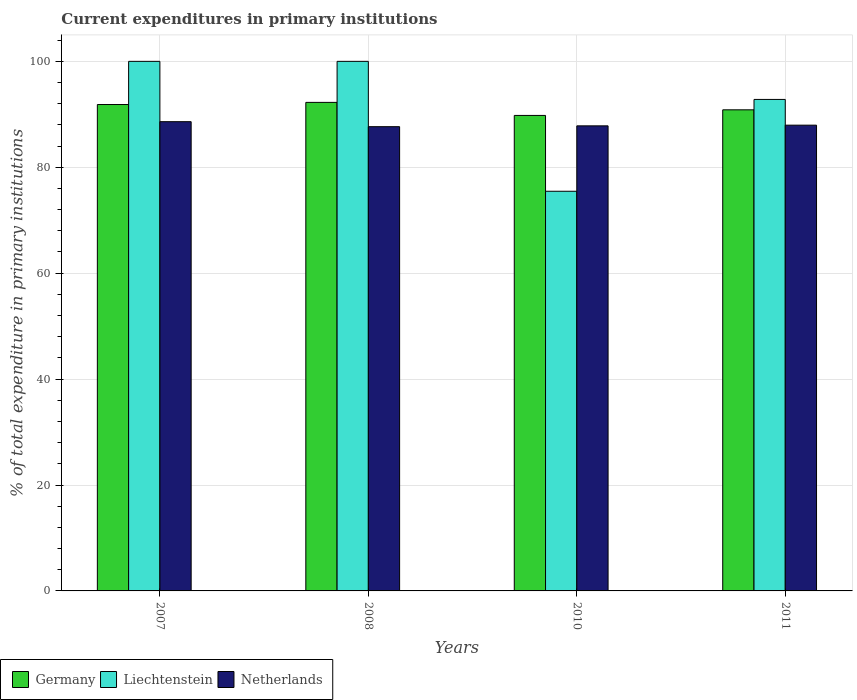How many different coloured bars are there?
Offer a very short reply. 3. Are the number of bars per tick equal to the number of legend labels?
Provide a short and direct response. Yes. How many bars are there on the 1st tick from the left?
Offer a terse response. 3. In how many cases, is the number of bars for a given year not equal to the number of legend labels?
Your answer should be very brief. 0. What is the current expenditures in primary institutions in Liechtenstein in 2008?
Your answer should be very brief. 100. Across all years, what is the maximum current expenditures in primary institutions in Germany?
Your answer should be very brief. 92.25. Across all years, what is the minimum current expenditures in primary institutions in Netherlands?
Provide a short and direct response. 87.67. In which year was the current expenditures in primary institutions in Liechtenstein minimum?
Your answer should be compact. 2010. What is the total current expenditures in primary institutions in Netherlands in the graph?
Keep it short and to the point. 352.04. What is the difference between the current expenditures in primary institutions in Germany in 2007 and that in 2010?
Provide a short and direct response. 2.06. What is the difference between the current expenditures in primary institutions in Liechtenstein in 2008 and the current expenditures in primary institutions in Germany in 2011?
Provide a succinct answer. 9.15. What is the average current expenditures in primary institutions in Germany per year?
Your response must be concise. 91.18. In the year 2008, what is the difference between the current expenditures in primary institutions in Netherlands and current expenditures in primary institutions in Liechtenstein?
Your response must be concise. -12.33. In how many years, is the current expenditures in primary institutions in Netherlands greater than 88 %?
Give a very brief answer. 1. What is the ratio of the current expenditures in primary institutions in Liechtenstein in 2008 to that in 2010?
Your answer should be compact. 1.33. Is the difference between the current expenditures in primary institutions in Netherlands in 2008 and 2010 greater than the difference between the current expenditures in primary institutions in Liechtenstein in 2008 and 2010?
Make the answer very short. No. What is the difference between the highest and the second highest current expenditures in primary institutions in Germany?
Give a very brief answer. 0.4. What is the difference between the highest and the lowest current expenditures in primary institutions in Liechtenstein?
Give a very brief answer. 24.53. In how many years, is the current expenditures in primary institutions in Liechtenstein greater than the average current expenditures in primary institutions in Liechtenstein taken over all years?
Provide a short and direct response. 3. What does the 2nd bar from the left in 2008 represents?
Keep it short and to the point. Liechtenstein. What does the 2nd bar from the right in 2011 represents?
Offer a very short reply. Liechtenstein. Are all the bars in the graph horizontal?
Your answer should be very brief. No. What is the difference between two consecutive major ticks on the Y-axis?
Your response must be concise. 20. Does the graph contain any zero values?
Your response must be concise. No. How many legend labels are there?
Ensure brevity in your answer.  3. What is the title of the graph?
Provide a succinct answer. Current expenditures in primary institutions. What is the label or title of the X-axis?
Your response must be concise. Years. What is the label or title of the Y-axis?
Keep it short and to the point. % of total expenditure in primary institutions. What is the % of total expenditure in primary institutions in Germany in 2007?
Your response must be concise. 91.85. What is the % of total expenditure in primary institutions of Liechtenstein in 2007?
Offer a terse response. 100. What is the % of total expenditure in primary institutions in Netherlands in 2007?
Provide a succinct answer. 88.61. What is the % of total expenditure in primary institutions in Germany in 2008?
Offer a terse response. 92.25. What is the % of total expenditure in primary institutions of Netherlands in 2008?
Provide a succinct answer. 87.67. What is the % of total expenditure in primary institutions of Germany in 2010?
Your response must be concise. 89.79. What is the % of total expenditure in primary institutions in Liechtenstein in 2010?
Ensure brevity in your answer.  75.47. What is the % of total expenditure in primary institutions in Netherlands in 2010?
Your answer should be compact. 87.82. What is the % of total expenditure in primary institutions in Germany in 2011?
Offer a very short reply. 90.85. What is the % of total expenditure in primary institutions in Liechtenstein in 2011?
Make the answer very short. 92.81. What is the % of total expenditure in primary institutions in Netherlands in 2011?
Offer a terse response. 87.95. Across all years, what is the maximum % of total expenditure in primary institutions in Germany?
Provide a short and direct response. 92.25. Across all years, what is the maximum % of total expenditure in primary institutions in Liechtenstein?
Ensure brevity in your answer.  100. Across all years, what is the maximum % of total expenditure in primary institutions in Netherlands?
Offer a very short reply. 88.61. Across all years, what is the minimum % of total expenditure in primary institutions of Germany?
Your response must be concise. 89.79. Across all years, what is the minimum % of total expenditure in primary institutions of Liechtenstein?
Your answer should be compact. 75.47. Across all years, what is the minimum % of total expenditure in primary institutions in Netherlands?
Keep it short and to the point. 87.67. What is the total % of total expenditure in primary institutions of Germany in the graph?
Ensure brevity in your answer.  364.74. What is the total % of total expenditure in primary institutions of Liechtenstein in the graph?
Make the answer very short. 368.28. What is the total % of total expenditure in primary institutions in Netherlands in the graph?
Your answer should be compact. 352.04. What is the difference between the % of total expenditure in primary institutions in Germany in 2007 and that in 2008?
Make the answer very short. -0.4. What is the difference between the % of total expenditure in primary institutions of Netherlands in 2007 and that in 2008?
Your answer should be very brief. 0.94. What is the difference between the % of total expenditure in primary institutions in Germany in 2007 and that in 2010?
Provide a succinct answer. 2.06. What is the difference between the % of total expenditure in primary institutions of Liechtenstein in 2007 and that in 2010?
Provide a succinct answer. 24.53. What is the difference between the % of total expenditure in primary institutions in Netherlands in 2007 and that in 2010?
Provide a succinct answer. 0.79. What is the difference between the % of total expenditure in primary institutions in Liechtenstein in 2007 and that in 2011?
Ensure brevity in your answer.  7.19. What is the difference between the % of total expenditure in primary institutions of Netherlands in 2007 and that in 2011?
Your response must be concise. 0.66. What is the difference between the % of total expenditure in primary institutions in Germany in 2008 and that in 2010?
Ensure brevity in your answer.  2.46. What is the difference between the % of total expenditure in primary institutions of Liechtenstein in 2008 and that in 2010?
Provide a succinct answer. 24.53. What is the difference between the % of total expenditure in primary institutions in Netherlands in 2008 and that in 2010?
Provide a succinct answer. -0.16. What is the difference between the % of total expenditure in primary institutions in Germany in 2008 and that in 2011?
Give a very brief answer. 1.4. What is the difference between the % of total expenditure in primary institutions of Liechtenstein in 2008 and that in 2011?
Offer a terse response. 7.19. What is the difference between the % of total expenditure in primary institutions of Netherlands in 2008 and that in 2011?
Give a very brief answer. -0.28. What is the difference between the % of total expenditure in primary institutions of Germany in 2010 and that in 2011?
Give a very brief answer. -1.06. What is the difference between the % of total expenditure in primary institutions in Liechtenstein in 2010 and that in 2011?
Give a very brief answer. -17.34. What is the difference between the % of total expenditure in primary institutions of Netherlands in 2010 and that in 2011?
Keep it short and to the point. -0.13. What is the difference between the % of total expenditure in primary institutions in Germany in 2007 and the % of total expenditure in primary institutions in Liechtenstein in 2008?
Keep it short and to the point. -8.15. What is the difference between the % of total expenditure in primary institutions of Germany in 2007 and the % of total expenditure in primary institutions of Netherlands in 2008?
Your response must be concise. 4.18. What is the difference between the % of total expenditure in primary institutions in Liechtenstein in 2007 and the % of total expenditure in primary institutions in Netherlands in 2008?
Provide a short and direct response. 12.33. What is the difference between the % of total expenditure in primary institutions of Germany in 2007 and the % of total expenditure in primary institutions of Liechtenstein in 2010?
Give a very brief answer. 16.38. What is the difference between the % of total expenditure in primary institutions of Germany in 2007 and the % of total expenditure in primary institutions of Netherlands in 2010?
Your answer should be very brief. 4.03. What is the difference between the % of total expenditure in primary institutions of Liechtenstein in 2007 and the % of total expenditure in primary institutions of Netherlands in 2010?
Your answer should be very brief. 12.18. What is the difference between the % of total expenditure in primary institutions in Germany in 2007 and the % of total expenditure in primary institutions in Liechtenstein in 2011?
Make the answer very short. -0.96. What is the difference between the % of total expenditure in primary institutions of Germany in 2007 and the % of total expenditure in primary institutions of Netherlands in 2011?
Offer a terse response. 3.9. What is the difference between the % of total expenditure in primary institutions in Liechtenstein in 2007 and the % of total expenditure in primary institutions in Netherlands in 2011?
Offer a terse response. 12.05. What is the difference between the % of total expenditure in primary institutions of Germany in 2008 and the % of total expenditure in primary institutions of Liechtenstein in 2010?
Provide a succinct answer. 16.78. What is the difference between the % of total expenditure in primary institutions of Germany in 2008 and the % of total expenditure in primary institutions of Netherlands in 2010?
Make the answer very short. 4.43. What is the difference between the % of total expenditure in primary institutions in Liechtenstein in 2008 and the % of total expenditure in primary institutions in Netherlands in 2010?
Provide a short and direct response. 12.18. What is the difference between the % of total expenditure in primary institutions in Germany in 2008 and the % of total expenditure in primary institutions in Liechtenstein in 2011?
Give a very brief answer. -0.56. What is the difference between the % of total expenditure in primary institutions of Germany in 2008 and the % of total expenditure in primary institutions of Netherlands in 2011?
Your response must be concise. 4.3. What is the difference between the % of total expenditure in primary institutions of Liechtenstein in 2008 and the % of total expenditure in primary institutions of Netherlands in 2011?
Your response must be concise. 12.05. What is the difference between the % of total expenditure in primary institutions in Germany in 2010 and the % of total expenditure in primary institutions in Liechtenstein in 2011?
Keep it short and to the point. -3.02. What is the difference between the % of total expenditure in primary institutions in Germany in 2010 and the % of total expenditure in primary institutions in Netherlands in 2011?
Ensure brevity in your answer.  1.84. What is the difference between the % of total expenditure in primary institutions in Liechtenstein in 2010 and the % of total expenditure in primary institutions in Netherlands in 2011?
Provide a short and direct response. -12.48. What is the average % of total expenditure in primary institutions in Germany per year?
Provide a short and direct response. 91.18. What is the average % of total expenditure in primary institutions in Liechtenstein per year?
Your answer should be very brief. 92.07. What is the average % of total expenditure in primary institutions of Netherlands per year?
Give a very brief answer. 88.01. In the year 2007, what is the difference between the % of total expenditure in primary institutions in Germany and % of total expenditure in primary institutions in Liechtenstein?
Provide a succinct answer. -8.15. In the year 2007, what is the difference between the % of total expenditure in primary institutions in Germany and % of total expenditure in primary institutions in Netherlands?
Ensure brevity in your answer.  3.24. In the year 2007, what is the difference between the % of total expenditure in primary institutions in Liechtenstein and % of total expenditure in primary institutions in Netherlands?
Provide a short and direct response. 11.39. In the year 2008, what is the difference between the % of total expenditure in primary institutions of Germany and % of total expenditure in primary institutions of Liechtenstein?
Ensure brevity in your answer.  -7.75. In the year 2008, what is the difference between the % of total expenditure in primary institutions in Germany and % of total expenditure in primary institutions in Netherlands?
Make the answer very short. 4.59. In the year 2008, what is the difference between the % of total expenditure in primary institutions in Liechtenstein and % of total expenditure in primary institutions in Netherlands?
Offer a very short reply. 12.33. In the year 2010, what is the difference between the % of total expenditure in primary institutions in Germany and % of total expenditure in primary institutions in Liechtenstein?
Offer a terse response. 14.32. In the year 2010, what is the difference between the % of total expenditure in primary institutions of Germany and % of total expenditure in primary institutions of Netherlands?
Your response must be concise. 1.97. In the year 2010, what is the difference between the % of total expenditure in primary institutions of Liechtenstein and % of total expenditure in primary institutions of Netherlands?
Provide a short and direct response. -12.35. In the year 2011, what is the difference between the % of total expenditure in primary institutions in Germany and % of total expenditure in primary institutions in Liechtenstein?
Give a very brief answer. -1.96. In the year 2011, what is the difference between the % of total expenditure in primary institutions in Germany and % of total expenditure in primary institutions in Netherlands?
Give a very brief answer. 2.9. In the year 2011, what is the difference between the % of total expenditure in primary institutions of Liechtenstein and % of total expenditure in primary institutions of Netherlands?
Keep it short and to the point. 4.86. What is the ratio of the % of total expenditure in primary institutions of Liechtenstein in 2007 to that in 2008?
Make the answer very short. 1. What is the ratio of the % of total expenditure in primary institutions of Netherlands in 2007 to that in 2008?
Provide a succinct answer. 1.01. What is the ratio of the % of total expenditure in primary institutions in Germany in 2007 to that in 2010?
Your response must be concise. 1.02. What is the ratio of the % of total expenditure in primary institutions in Liechtenstein in 2007 to that in 2010?
Your answer should be very brief. 1.32. What is the ratio of the % of total expenditure in primary institutions of Netherlands in 2007 to that in 2010?
Provide a succinct answer. 1.01. What is the ratio of the % of total expenditure in primary institutions of Liechtenstein in 2007 to that in 2011?
Offer a very short reply. 1.08. What is the ratio of the % of total expenditure in primary institutions of Netherlands in 2007 to that in 2011?
Provide a succinct answer. 1.01. What is the ratio of the % of total expenditure in primary institutions in Germany in 2008 to that in 2010?
Your response must be concise. 1.03. What is the ratio of the % of total expenditure in primary institutions of Liechtenstein in 2008 to that in 2010?
Ensure brevity in your answer.  1.32. What is the ratio of the % of total expenditure in primary institutions in Germany in 2008 to that in 2011?
Your answer should be compact. 1.02. What is the ratio of the % of total expenditure in primary institutions in Liechtenstein in 2008 to that in 2011?
Keep it short and to the point. 1.08. What is the ratio of the % of total expenditure in primary institutions of Germany in 2010 to that in 2011?
Ensure brevity in your answer.  0.99. What is the ratio of the % of total expenditure in primary institutions in Liechtenstein in 2010 to that in 2011?
Your answer should be compact. 0.81. What is the difference between the highest and the second highest % of total expenditure in primary institutions of Germany?
Give a very brief answer. 0.4. What is the difference between the highest and the second highest % of total expenditure in primary institutions of Netherlands?
Provide a short and direct response. 0.66. What is the difference between the highest and the lowest % of total expenditure in primary institutions of Germany?
Your answer should be compact. 2.46. What is the difference between the highest and the lowest % of total expenditure in primary institutions of Liechtenstein?
Provide a succinct answer. 24.53. What is the difference between the highest and the lowest % of total expenditure in primary institutions in Netherlands?
Keep it short and to the point. 0.94. 